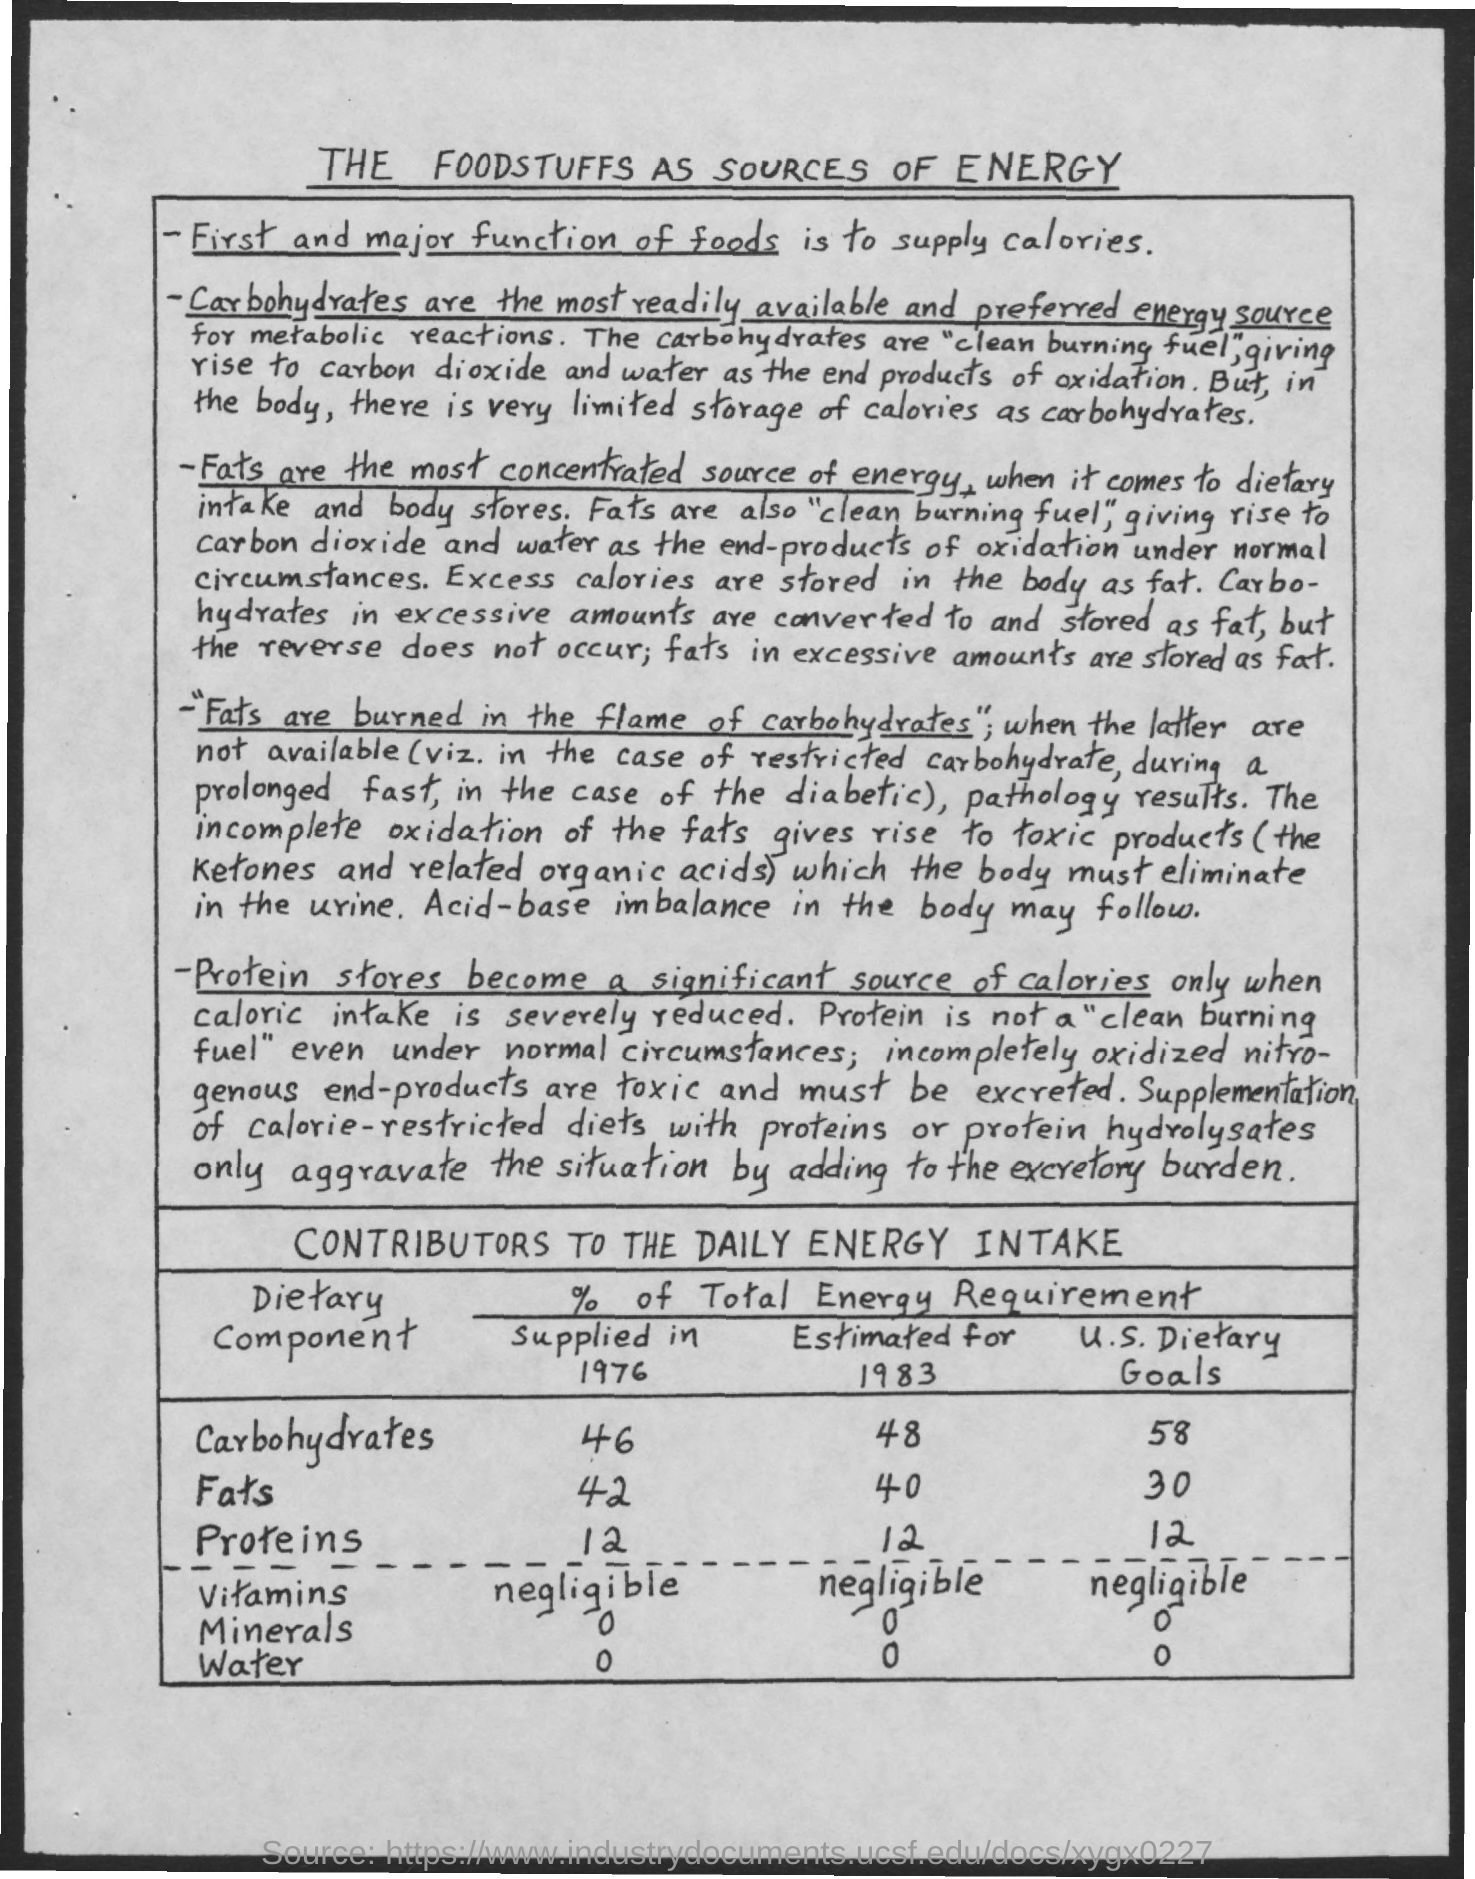Indicate a few pertinent items in this graphic. In 1976, 42% of the fats consumed were supplied. Carbohydrates are the most commonly accessible and widely preferred source of energy for the body. Fats are the most concentrated source of energy. The title of the document is "What is the Foodstuffs as Sources of Energy?". 